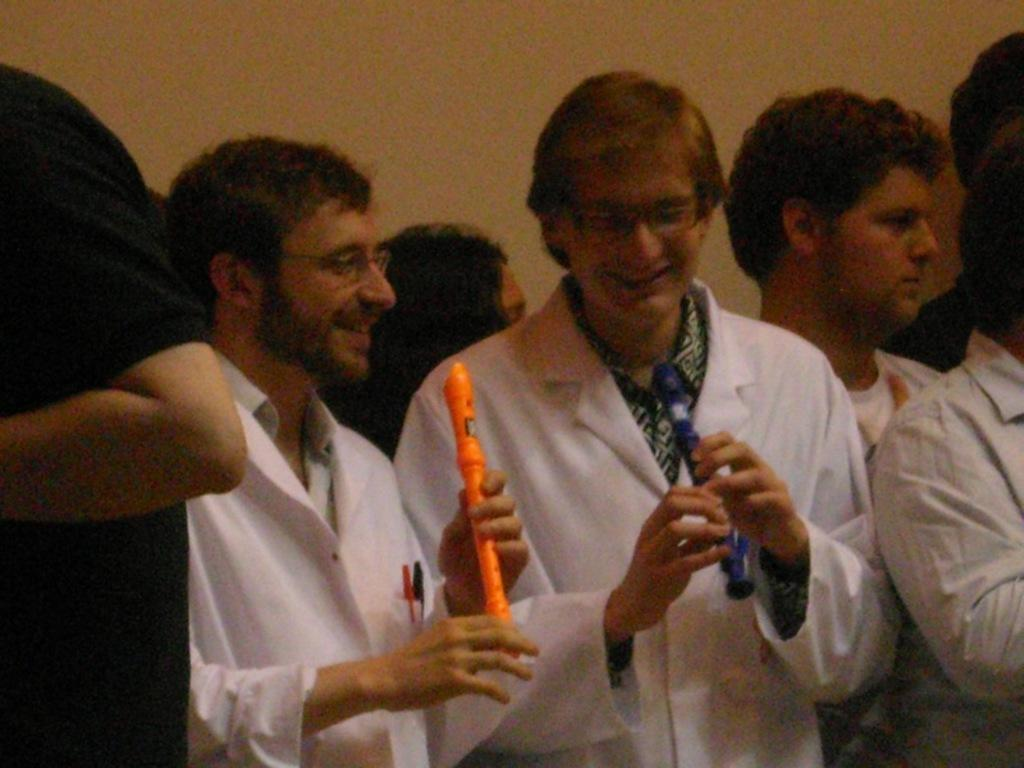How many people are in the group shown in the image? There is a group of persons in the image. What are the two persons in white suits holding in their hands? The two persons in white suits are holding an object in their hands. What type of hill can be seen in the background of the image? There is no hill visible in the image. Who is the manager of the group in the image? The provided facts do not mention a manager or any hierarchy within the group. 